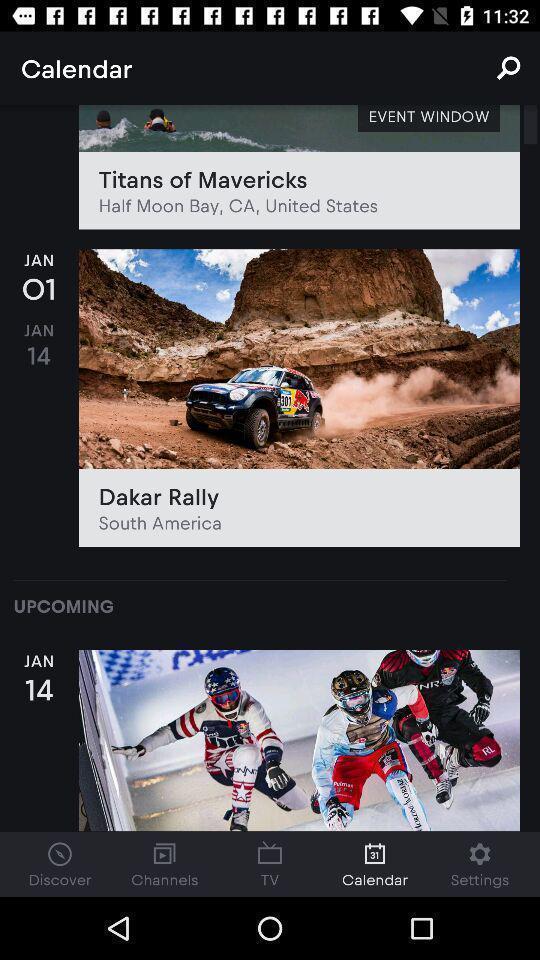Summarize the information in this screenshot. Page showing the thumbnails in of future schedules. 